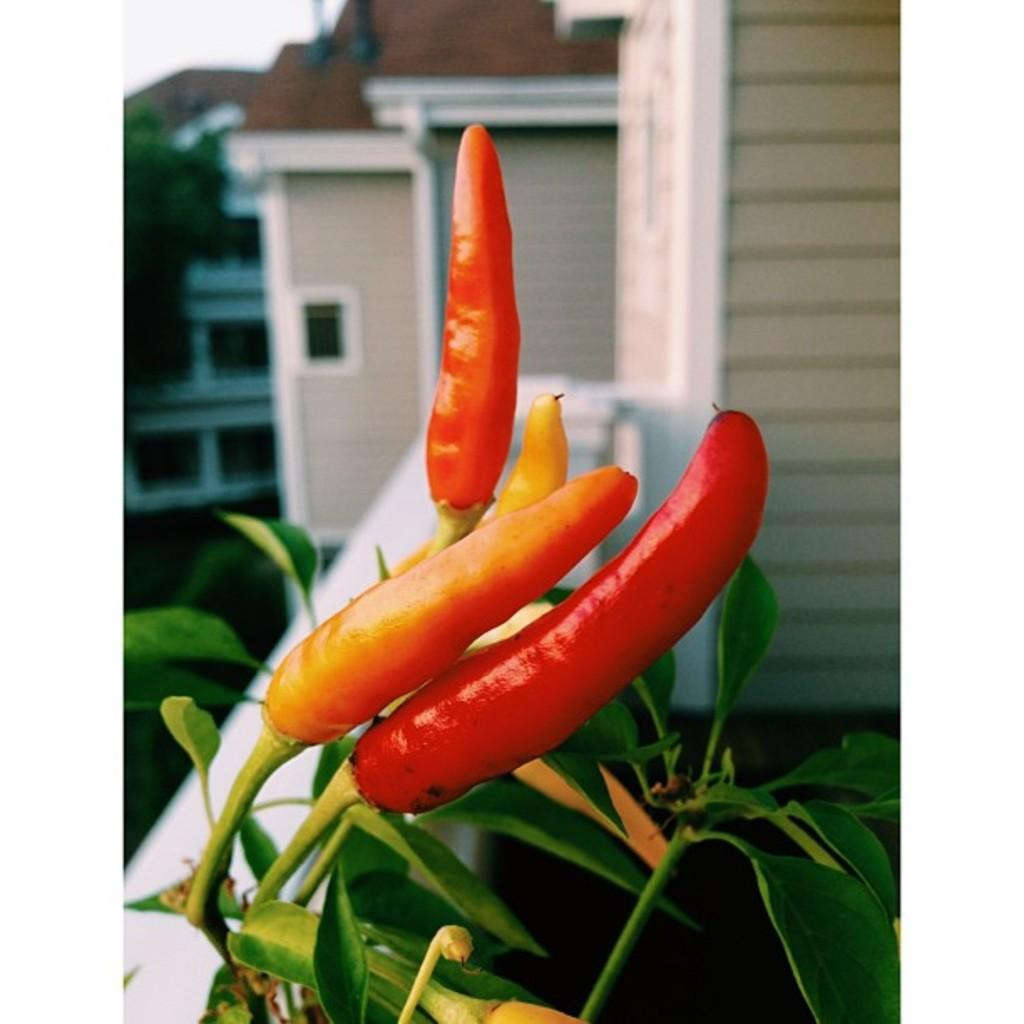What type of plant is in the image? There is a red chilies plant in the image. What can be found on the plant besides the chilies? The plant has leaves. What else can be seen in the image besides the plant? There are buildings visible in the image. What type of education is being offered at the breakfast table in the image? There is no breakfast table or education being offered in the image; it features a red chilies plant and buildings. 